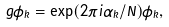Convert formula to latex. <formula><loc_0><loc_0><loc_500><loc_500>g \phi _ { k } = \exp ( 2 \pi i \alpha _ { k } / N ) \phi _ { k } ,</formula> 